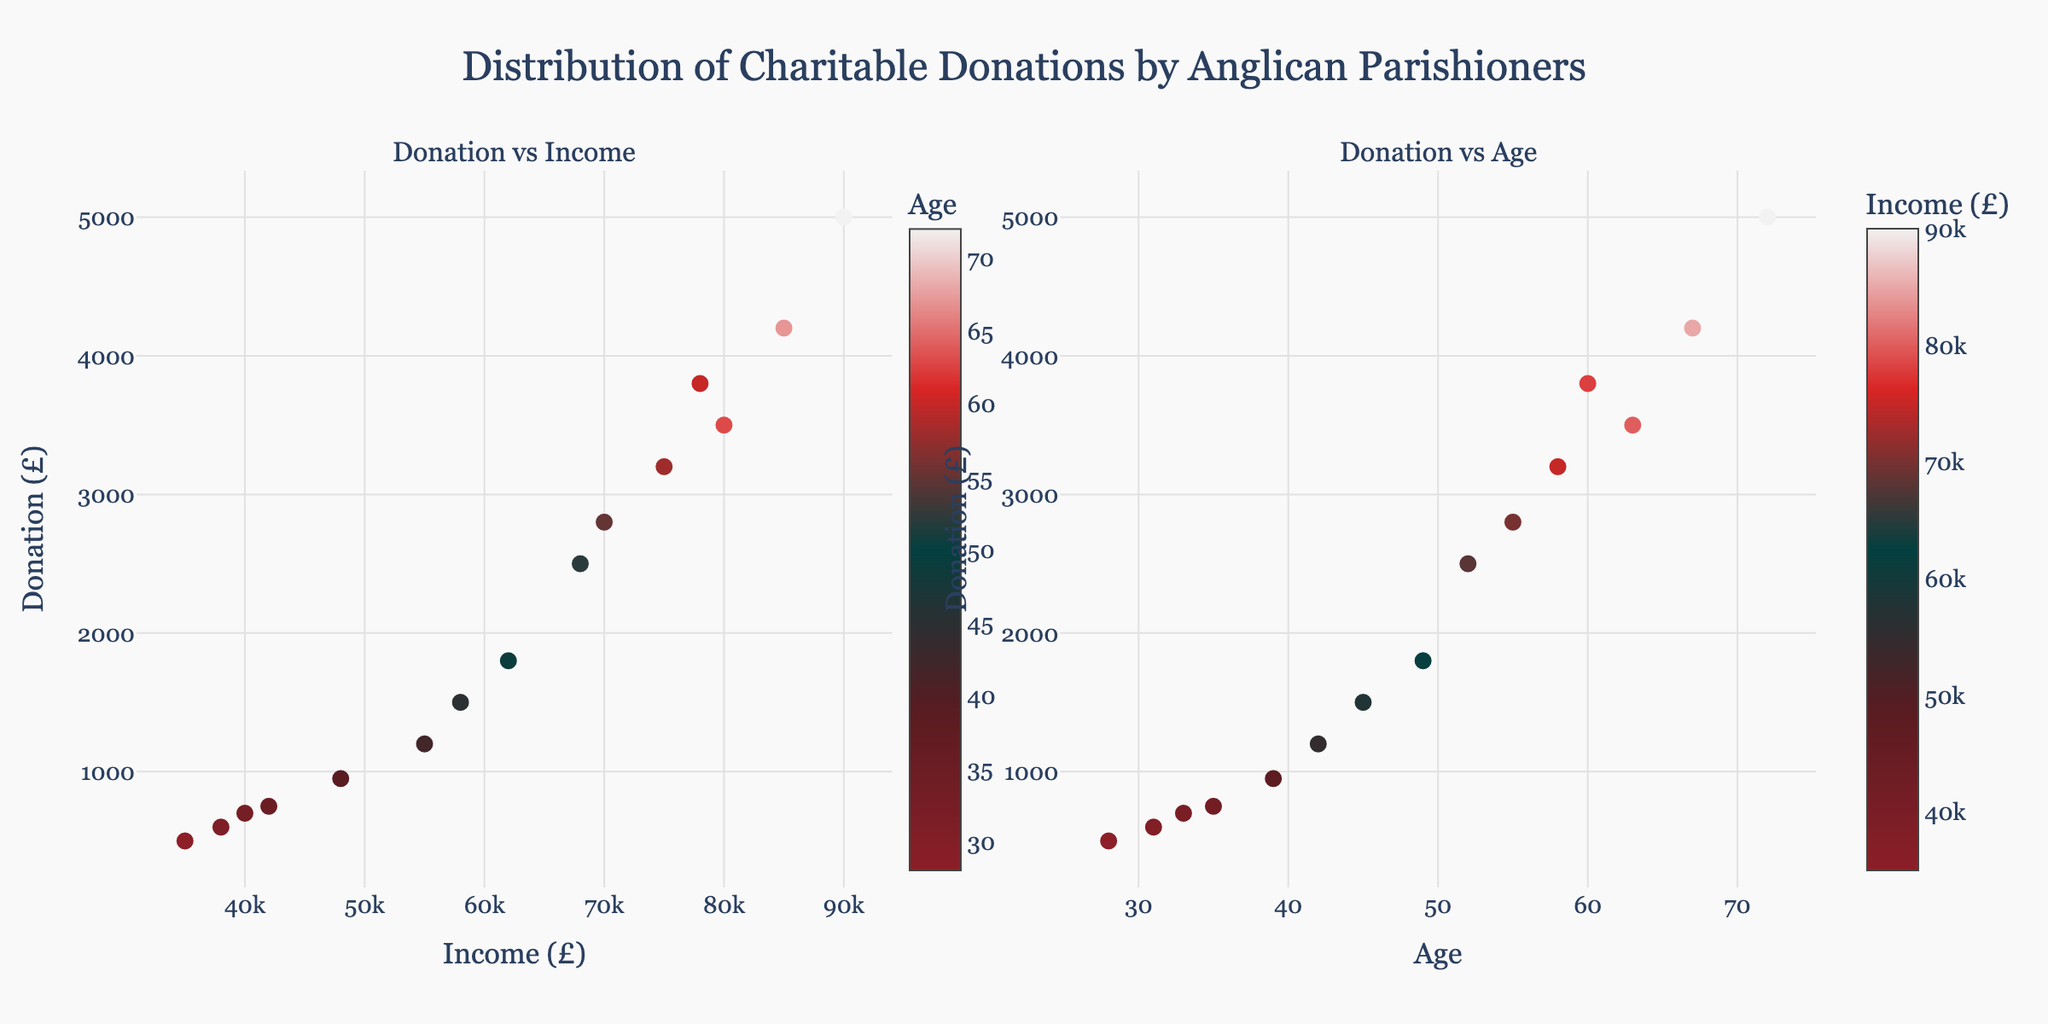What is the title of the plot? The title of the plot is located above the subplots and is presented in a larger font size for prominence.
Answer: Distribution of Charitable Donations by Anglican Parishioners What are the axes labels for the "Donation vs Income" subplot? The axes labels for the "Donation vs Income" subplot are found along the horizontal and vertical edges of the plot area. The horizontal axis is labeled "Income (£)" and the vertical axis is labeled "Donation (£)".
Answer: Income (£) and Donation (£) How many data points are plotted in the "Donation vs Age" subplot? The number of data points can be observed by counting the distinct markers visible on the "Donation vs Age" subplot.
Answer: 15 Which parish has the highest donation, and what is that donation? By comparing the donation values, the highest donation stands out. Hovering over the data points typically reveals this information alongside the parish names. The highest donation is £5000, given by Southwark Cathedral.
Answer: Southwark Cathedral, £5000 How does the graph represent the age information in the "Donation vs Income" subplot? In the "Donation vs Income" subplot, the age information is encoded using a color scale on the markers, with a color bar legend indicating the age distribution.
Answer: By marker color Which age group has the highest income level? To find the highest income level, refer to the color bar legend for ages and compare the income values corresponding to different age groups. The 72-year-old from Southwark Cathedral has the highest income at £90000.
Answer: Age 72 (Southwark Cathedral) What is the typical donation amount for parishioners between the ages of 30 and 40? By observing the "Donation vs Age" subplot, the donation amounts for parishioners in the age range 30-40, including any relevant data points, typically fall between £500 and £950.
Answer: Between £500 and £950 Compare the donations made by parishioners of St. Mary's Lambeth and Christ Church Spitalfields. Who donated more? The donated amounts, visible by hovering over the data points labeled with parish names, show that Christ Church Spitalfields donated £2800, while St. Mary's Lambeth donated £500.
Answer: Christ Church Spitalfields Which subgroup, divided by age and income, shows the highest tendency to donate more than £3000? Analyzing both subplots, the markers with donations over £3000 are mostly concentrated among the older age group (60+), with higher incomes generally above £75000.
Answer: Older age (60+) and high income (>£75000) How is the data point for St. Paul's Cathedral characterized in the plots? By locating the data point for St. Paul's Cathedral and referring to both plots, St. Paul's Cathedral has an income of £80000, age 63, and a donation of £3500. The color and position confirm this information.
Answer: Age 63, Income £80000, Donation £3500 